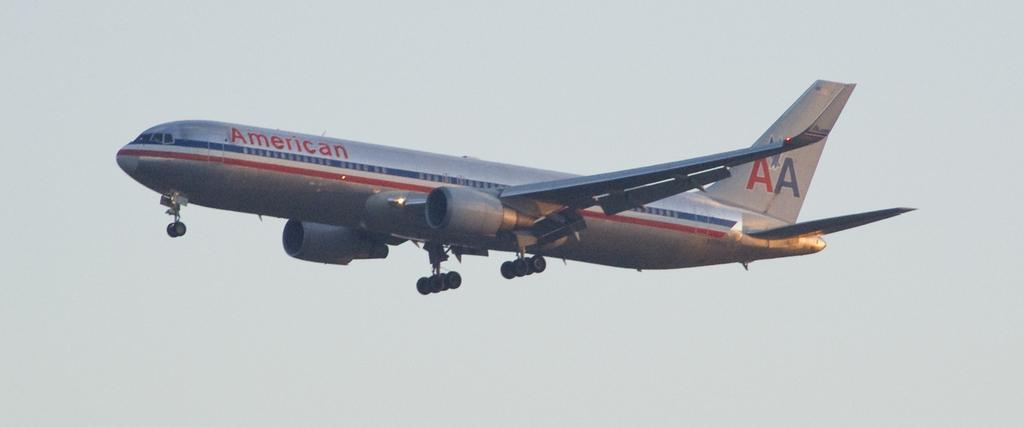How would you summarize this image in a sentence or two? In this picture we can see an airplane and it is in the air. 